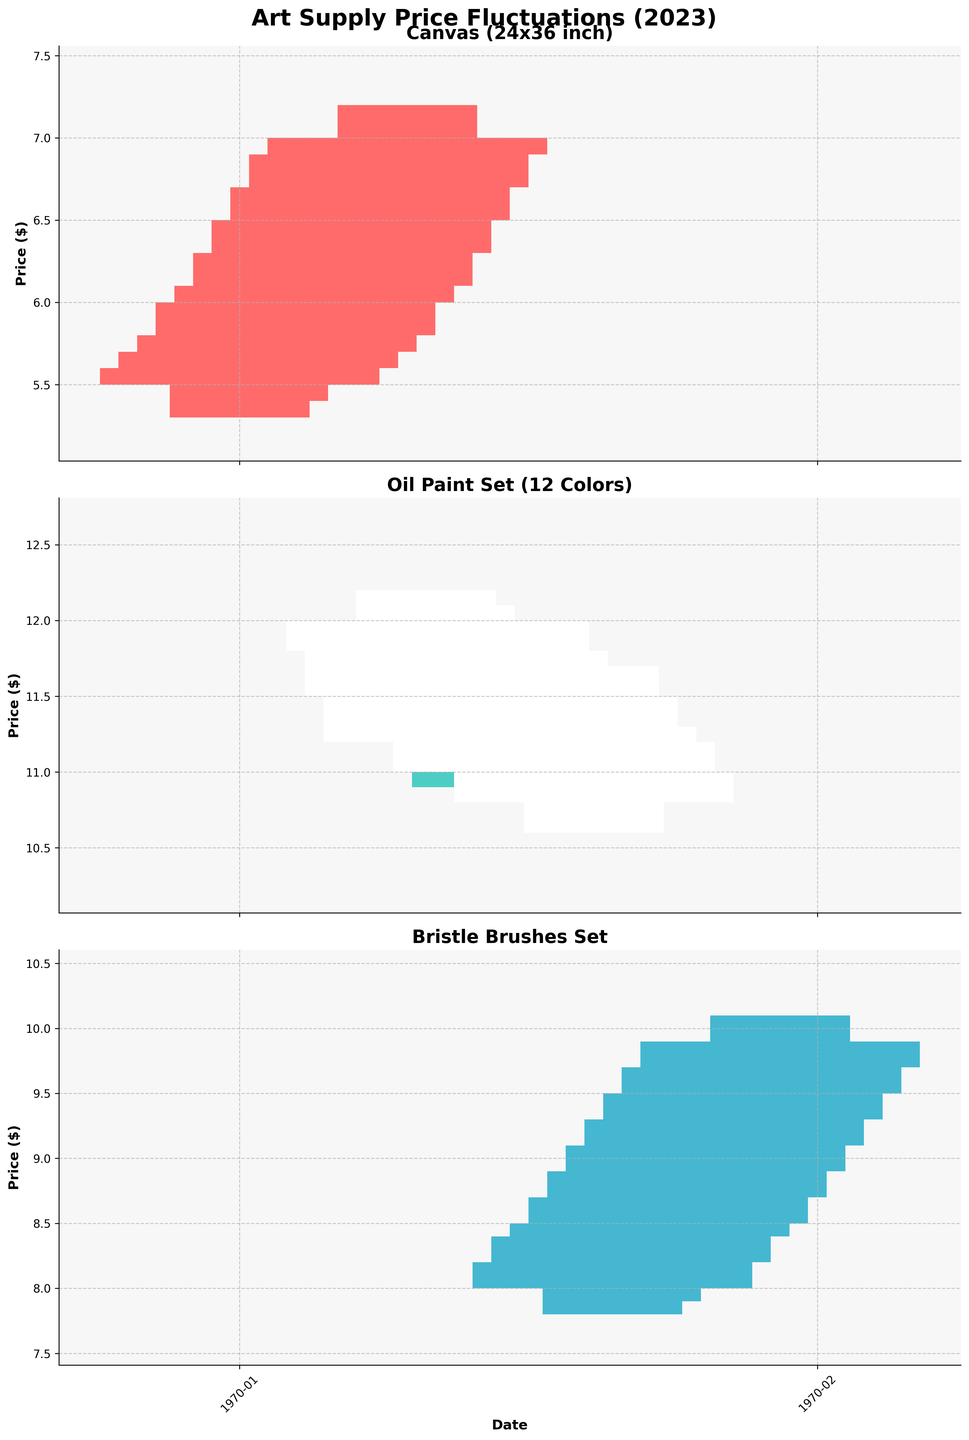How many different art supplies are shown in the figure? The figure has three different art supplies plots. Each plot represents a different type of art supply as labeled in the titles of the subplots.
Answer: 3 Which art supply experienced the largest increase in price from January to October? To determine the largest increase, we compare the closing prices in January and October for each art supply. For Canvas, the price increased from $5.60 to $7.00; for Oil Paint Set, from $11.80 to $10.80 (a decrease); and for Bristle Brushes Set, from $8.20 to $9.90. Thus, Canvas had the largest increase.
Answer: Canvas (24x36 inch) What is the highest price recorded for the Bristle Brushes Set? The highest price recorded can be found in the 'High' columns for the Bristle Brushes Set across all months. The highest value is $10.10, recorded in October.
Answer: $10.10 Which month showed the greatest price drop in the Oil Paint Set? To find the greatest price drop, we compare the opening and closing prices each month. In March, the opening was $11.50 and the closing was $11.20, marking a $0.30 drop as the largest observed.
Answer: March Did the Canvas (24x36 inch) drop below $6.00 at any point during the year? The 'Low' column for Canvas (24x36 inch) needs to be checked for any values below $6.00. In the early months such as January, February, March, and April, the 'Low' prices are $5.30, $5.40, $5.50, and $5.60, respectively, indicating that the price dropped below $6.00 in those months.
Answer: Yes Has the closing price for the Bristle Brushes Set ever been lower than its opening price? We need to check the close and open prices for each month for the Bristle Brushes Set. In each month provided, the closing prices are not lower than the opening prices.
Answer: No Which art supply has the most stable prices based on high and low values? By comparing the range (High - Low) for each art supply month by month, we observe that the Oil Paint Set generally shows smaller deviations between high and low prices relative to the other supplies.
Answer: Oil Paint Set Was there any month when all three art supplies had their prices close higher than they opened? By inspecting the closing and opening prices for January to October for all three supplies, we see in August all of them; Bristle Brushes Set ($9.50 vs $9.30), Oil Paint Set ($11.20 vs $11.30), and Canvas ($6.70 vs $6.50) had closing prices higher than opening prices.
Answer: August 